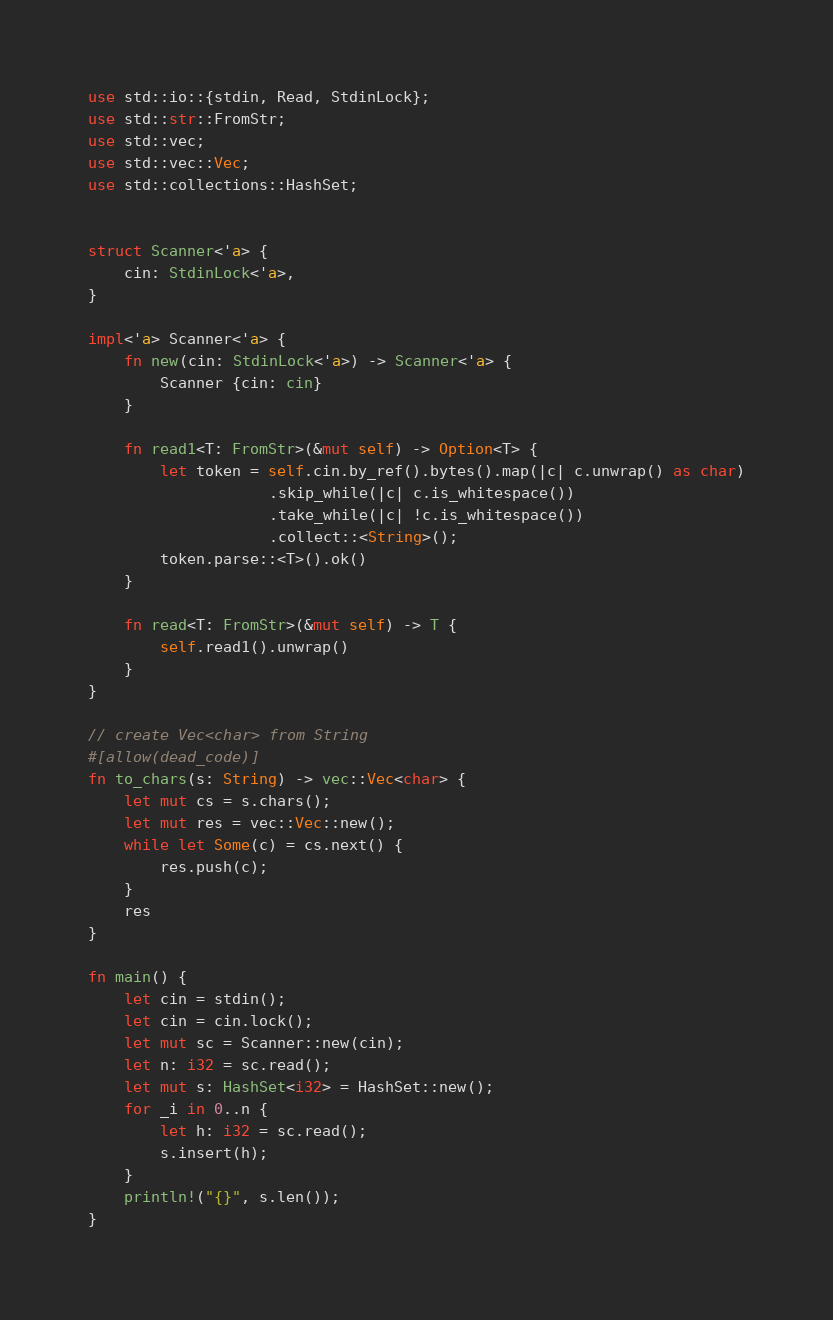<code> <loc_0><loc_0><loc_500><loc_500><_Rust_>use std::io::{stdin, Read, StdinLock};
use std::str::FromStr;
use std::vec;
use std::vec::Vec;
use std::collections::HashSet;


struct Scanner<'a> {
    cin: StdinLock<'a>,
}

impl<'a> Scanner<'a> {
    fn new(cin: StdinLock<'a>) -> Scanner<'a> {
        Scanner {cin: cin}
    }

    fn read1<T: FromStr>(&mut self) -> Option<T> {
        let token = self.cin.by_ref().bytes().map(|c| c.unwrap() as char)
                    .skip_while(|c| c.is_whitespace())
                    .take_while(|c| !c.is_whitespace())
                    .collect::<String>();
        token.parse::<T>().ok()
    }

    fn read<T: FromStr>(&mut self) -> T {
        self.read1().unwrap()
    }
}

// create Vec<char> from String
#[allow(dead_code)]
fn to_chars(s: String) -> vec::Vec<char> {
    let mut cs = s.chars();
    let mut res = vec::Vec::new();
    while let Some(c) = cs.next() {
        res.push(c);
    }
    res
}

fn main() {
    let cin = stdin();
    let cin = cin.lock();
    let mut sc = Scanner::new(cin);
    let n: i32 = sc.read();
    let mut s: HashSet<i32> = HashSet::new();
    for _i in 0..n {
        let h: i32 = sc.read();
        s.insert(h);
    }
    println!("{}", s.len());
}</code> 